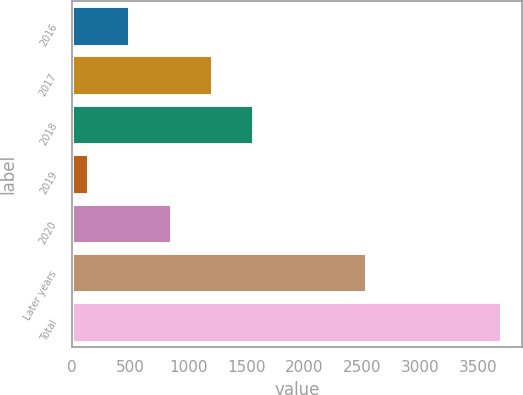Convert chart to OTSL. <chart><loc_0><loc_0><loc_500><loc_500><bar_chart><fcel>2016<fcel>2017<fcel>2018<fcel>2019<fcel>2020<fcel>Later years<fcel>Total<nl><fcel>493.8<fcel>1204.8<fcel>1560.3<fcel>138.3<fcel>849.3<fcel>2529.6<fcel>3693.3<nl></chart> 